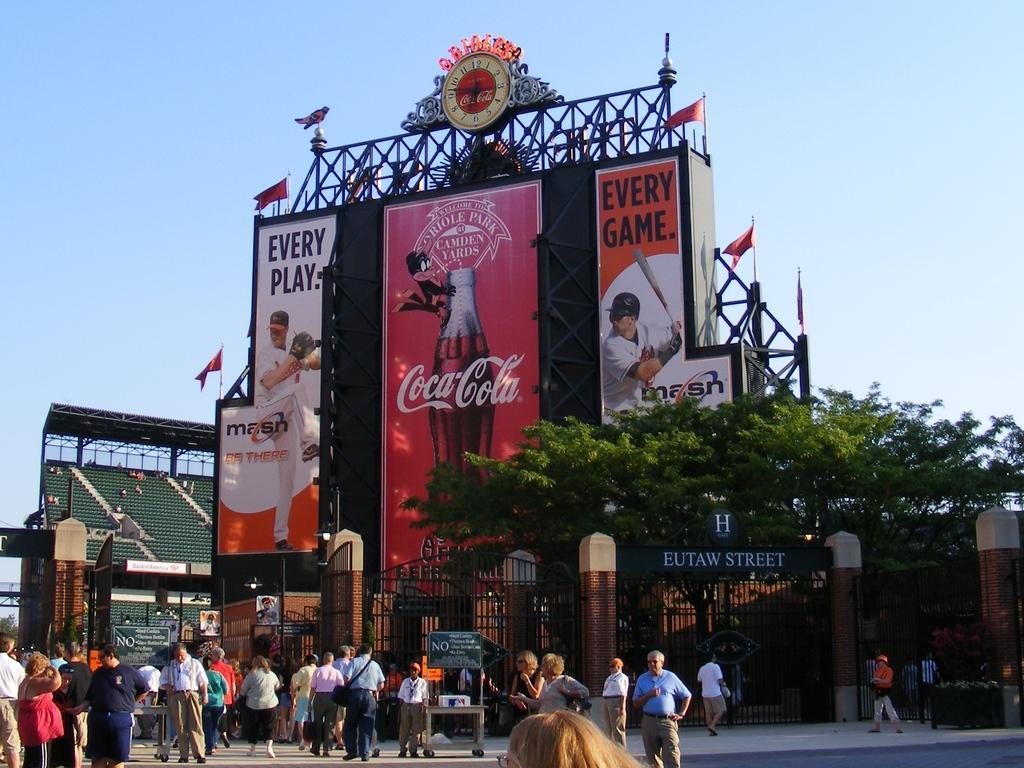Can you describe this image briefly? This image is clicked on the road. There are many people standing on the road. Behind them there is a railing. There is a board with text on the railing. In the background there is a hoarding. There are pictures and text on the hoarding. At the top of the hoarding there is a clock. In front of the hoarding there is a tree. To the left there are seats. It seems to be a stadium. At the top there is the sky. 